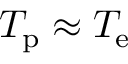Convert formula to latex. <formula><loc_0><loc_0><loc_500><loc_500>T _ { p } \approx T _ { e }</formula> 